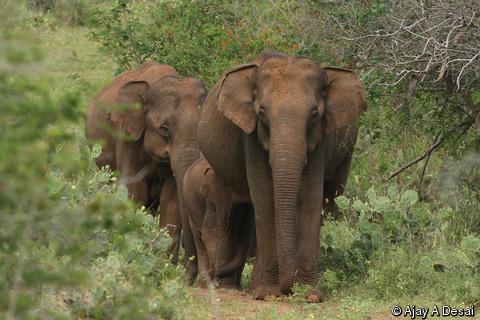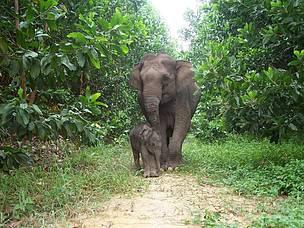The first image is the image on the left, the second image is the image on the right. Analyze the images presented: Is the assertion "The right image shows just one baby elephant next to one adult." valid? Answer yes or no. Yes. 